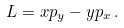Convert formula to latex. <formula><loc_0><loc_0><loc_500><loc_500>L = x p _ { y } - y p _ { x } \, .</formula> 